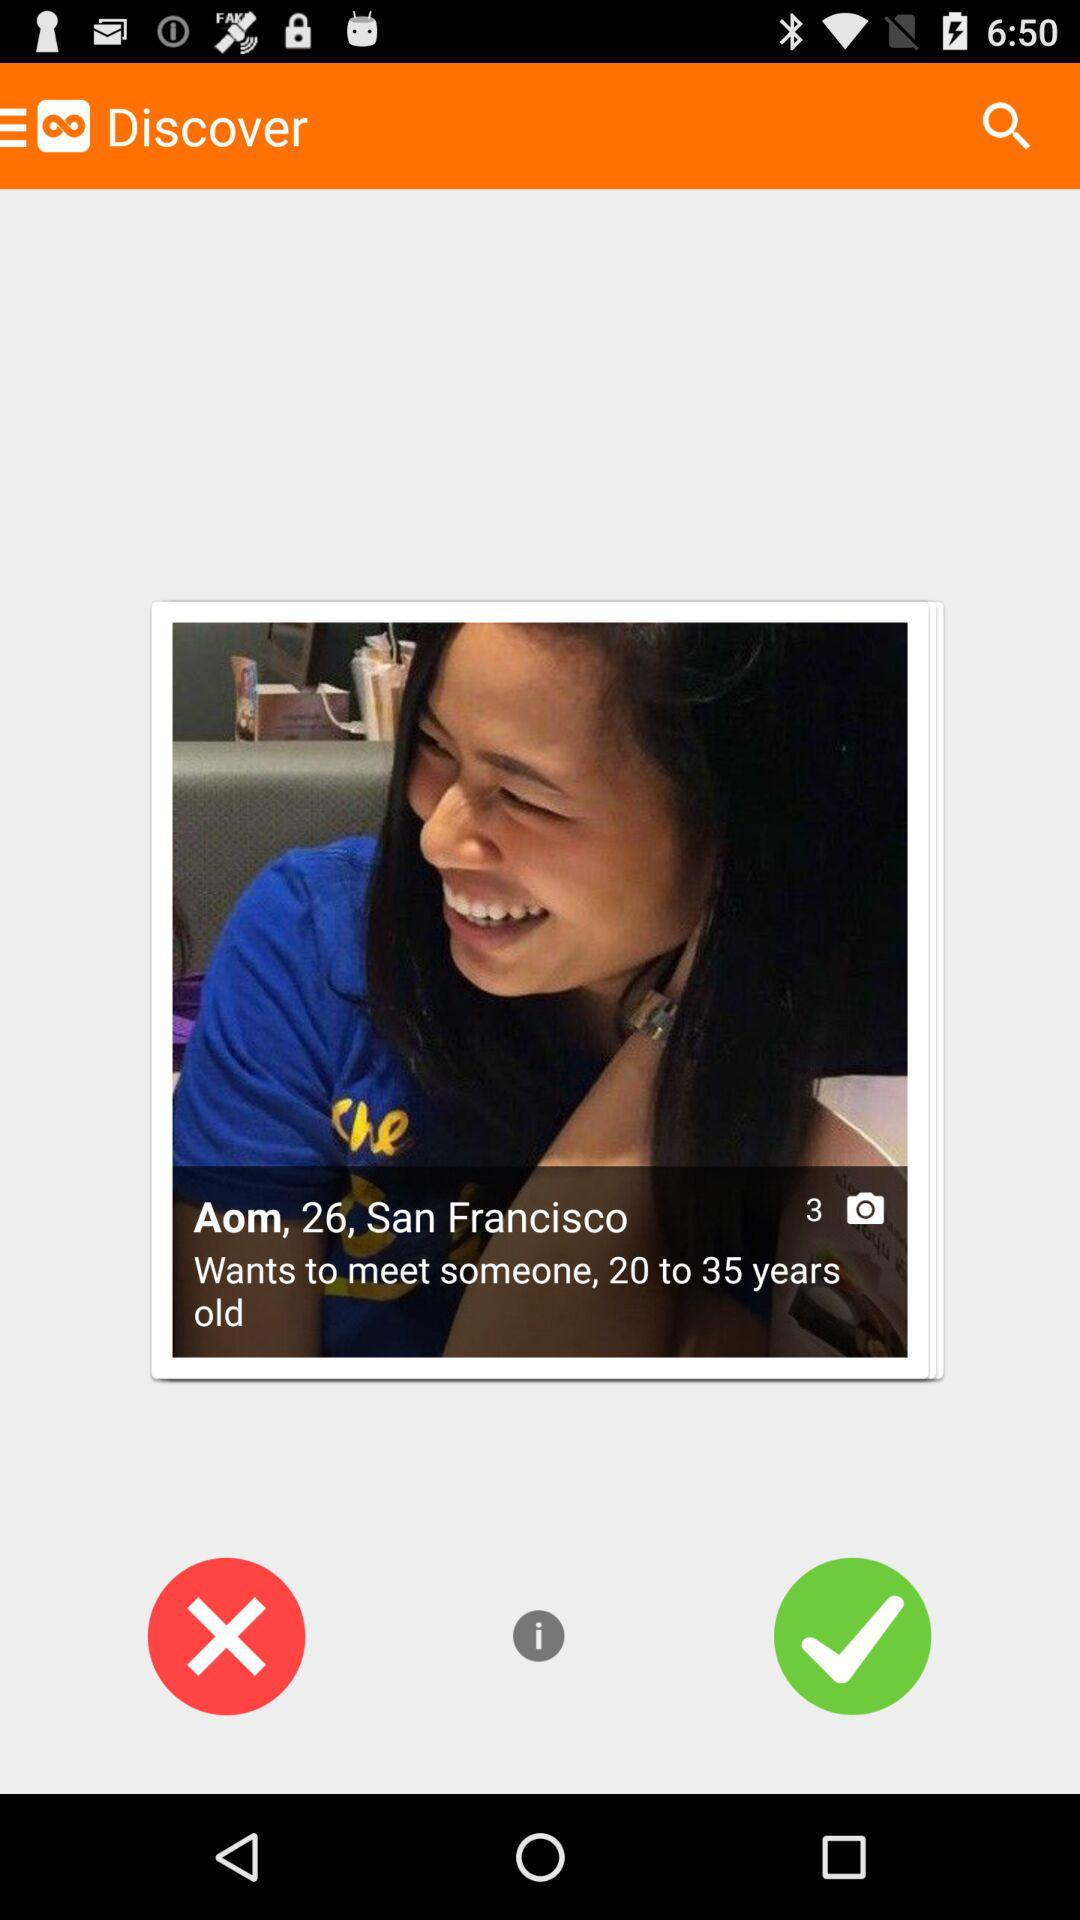What is the user name? The user name is Aom. 